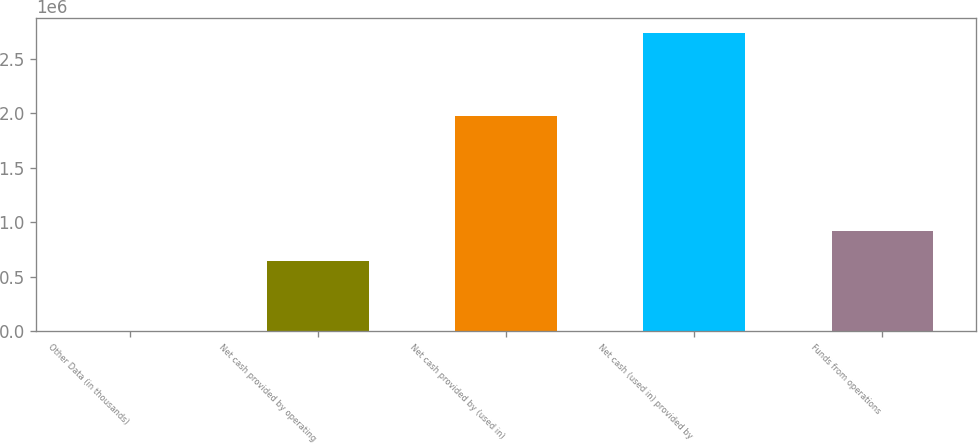<chart> <loc_0><loc_0><loc_500><loc_500><bar_chart><fcel>Other Data (in thousands)<fcel>Net cash provided by operating<fcel>Net cash provided by (used in)<fcel>Net cash (used in) provided by<fcel>Funds from operations<nl><fcel>2016<fcel>644010<fcel>1.97338e+06<fcel>2.7364e+06<fcel>917449<nl></chart> 